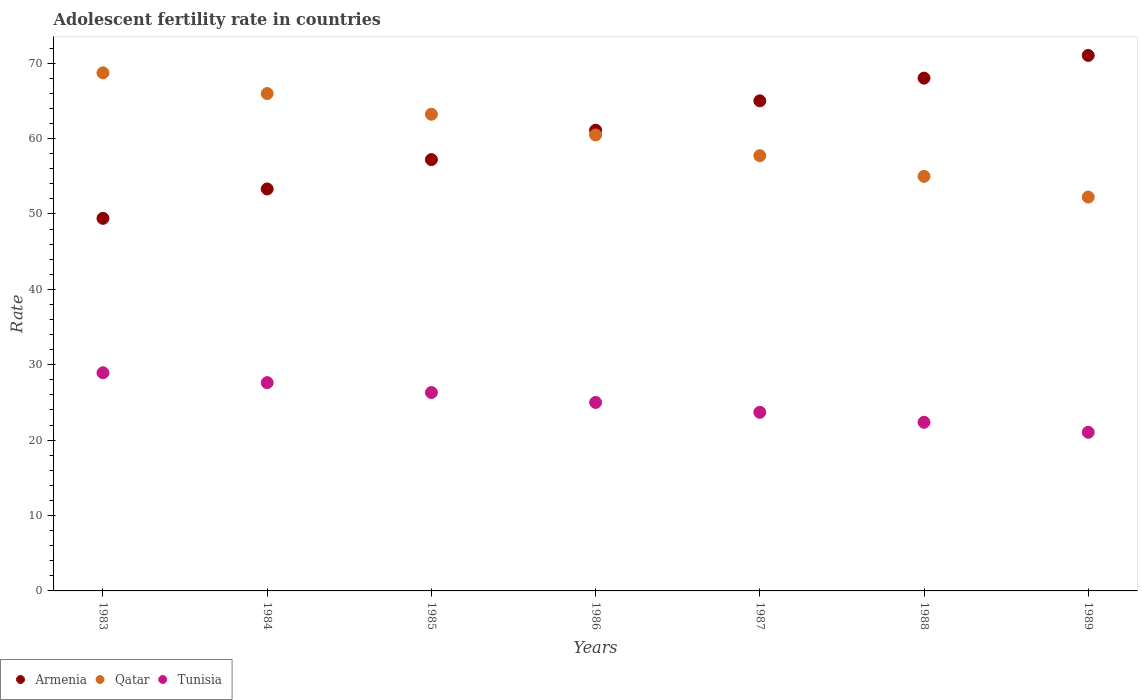Is the number of dotlines equal to the number of legend labels?
Keep it short and to the point. Yes. What is the adolescent fertility rate in Armenia in 1983?
Ensure brevity in your answer.  49.42. Across all years, what is the maximum adolescent fertility rate in Armenia?
Your answer should be very brief. 71.03. Across all years, what is the minimum adolescent fertility rate in Qatar?
Your response must be concise. 52.24. In which year was the adolescent fertility rate in Tunisia maximum?
Make the answer very short. 1983. What is the total adolescent fertility rate in Armenia in the graph?
Make the answer very short. 425.12. What is the difference between the adolescent fertility rate in Tunisia in 1987 and that in 1989?
Provide a succinct answer. 2.65. What is the difference between the adolescent fertility rate in Tunisia in 1984 and the adolescent fertility rate in Armenia in 1986?
Offer a very short reply. -33.48. What is the average adolescent fertility rate in Tunisia per year?
Keep it short and to the point. 25. In the year 1985, what is the difference between the adolescent fertility rate in Qatar and adolescent fertility rate in Tunisia?
Provide a short and direct response. 36.91. What is the ratio of the adolescent fertility rate in Qatar in 1988 to that in 1989?
Provide a short and direct response. 1.05. Is the adolescent fertility rate in Tunisia in 1984 less than that in 1987?
Make the answer very short. No. What is the difference between the highest and the second highest adolescent fertility rate in Armenia?
Give a very brief answer. 3.01. What is the difference between the highest and the lowest adolescent fertility rate in Tunisia?
Offer a very short reply. 7.9. In how many years, is the adolescent fertility rate in Armenia greater than the average adolescent fertility rate in Armenia taken over all years?
Give a very brief answer. 4. Is the sum of the adolescent fertility rate in Tunisia in 1984 and 1989 greater than the maximum adolescent fertility rate in Qatar across all years?
Give a very brief answer. No. Is it the case that in every year, the sum of the adolescent fertility rate in Qatar and adolescent fertility rate in Tunisia  is greater than the adolescent fertility rate in Armenia?
Your response must be concise. Yes. Is the adolescent fertility rate in Tunisia strictly greater than the adolescent fertility rate in Armenia over the years?
Keep it short and to the point. No. Is the adolescent fertility rate in Tunisia strictly less than the adolescent fertility rate in Armenia over the years?
Keep it short and to the point. Yes. How many years are there in the graph?
Offer a very short reply. 7. Does the graph contain any zero values?
Keep it short and to the point. No. Where does the legend appear in the graph?
Provide a succinct answer. Bottom left. How are the legend labels stacked?
Provide a succinct answer. Horizontal. What is the title of the graph?
Offer a very short reply. Adolescent fertility rate in countries. What is the label or title of the Y-axis?
Your answer should be very brief. Rate. What is the Rate in Armenia in 1983?
Offer a terse response. 49.42. What is the Rate in Qatar in 1983?
Provide a succinct answer. 68.72. What is the Rate in Tunisia in 1983?
Provide a succinct answer. 28.94. What is the Rate of Armenia in 1984?
Offer a very short reply. 53.32. What is the Rate in Qatar in 1984?
Keep it short and to the point. 65.98. What is the Rate in Tunisia in 1984?
Keep it short and to the point. 27.63. What is the Rate in Armenia in 1985?
Give a very brief answer. 57.21. What is the Rate in Qatar in 1985?
Offer a very short reply. 63.23. What is the Rate of Tunisia in 1985?
Provide a succinct answer. 26.31. What is the Rate in Armenia in 1986?
Keep it short and to the point. 61.11. What is the Rate in Qatar in 1986?
Offer a very short reply. 60.48. What is the Rate in Tunisia in 1986?
Provide a succinct answer. 25. What is the Rate in Armenia in 1987?
Your response must be concise. 65.01. What is the Rate of Qatar in 1987?
Ensure brevity in your answer.  57.74. What is the Rate in Tunisia in 1987?
Your response must be concise. 23.69. What is the Rate of Armenia in 1988?
Provide a succinct answer. 68.02. What is the Rate in Qatar in 1988?
Keep it short and to the point. 54.99. What is the Rate of Tunisia in 1988?
Provide a short and direct response. 22.37. What is the Rate of Armenia in 1989?
Your answer should be compact. 71.03. What is the Rate in Qatar in 1989?
Offer a very short reply. 52.24. What is the Rate of Tunisia in 1989?
Your answer should be compact. 21.04. Across all years, what is the maximum Rate in Armenia?
Provide a short and direct response. 71.03. Across all years, what is the maximum Rate of Qatar?
Offer a terse response. 68.72. Across all years, what is the maximum Rate in Tunisia?
Make the answer very short. 28.94. Across all years, what is the minimum Rate of Armenia?
Your response must be concise. 49.42. Across all years, what is the minimum Rate in Qatar?
Make the answer very short. 52.24. Across all years, what is the minimum Rate of Tunisia?
Ensure brevity in your answer.  21.04. What is the total Rate in Armenia in the graph?
Keep it short and to the point. 425.12. What is the total Rate of Qatar in the graph?
Ensure brevity in your answer.  423.38. What is the total Rate of Tunisia in the graph?
Your response must be concise. 174.98. What is the difference between the Rate of Armenia in 1983 and that in 1984?
Make the answer very short. -3.9. What is the difference between the Rate in Qatar in 1983 and that in 1984?
Your response must be concise. 2.75. What is the difference between the Rate of Tunisia in 1983 and that in 1984?
Offer a terse response. 1.31. What is the difference between the Rate of Armenia in 1983 and that in 1985?
Offer a very short reply. -7.79. What is the difference between the Rate of Qatar in 1983 and that in 1985?
Make the answer very short. 5.49. What is the difference between the Rate of Tunisia in 1983 and that in 1985?
Provide a succinct answer. 2.62. What is the difference between the Rate of Armenia in 1983 and that in 1986?
Your response must be concise. -11.69. What is the difference between the Rate in Qatar in 1983 and that in 1986?
Ensure brevity in your answer.  8.24. What is the difference between the Rate of Tunisia in 1983 and that in 1986?
Provide a succinct answer. 3.94. What is the difference between the Rate of Armenia in 1983 and that in 1987?
Make the answer very short. -15.59. What is the difference between the Rate of Qatar in 1983 and that in 1987?
Offer a very short reply. 10.99. What is the difference between the Rate in Tunisia in 1983 and that in 1987?
Provide a succinct answer. 5.25. What is the difference between the Rate of Armenia in 1983 and that in 1988?
Offer a very short reply. -18.6. What is the difference between the Rate of Qatar in 1983 and that in 1988?
Give a very brief answer. 13.73. What is the difference between the Rate in Tunisia in 1983 and that in 1988?
Offer a very short reply. 6.57. What is the difference between the Rate in Armenia in 1983 and that in 1989?
Provide a succinct answer. -21.61. What is the difference between the Rate of Qatar in 1983 and that in 1989?
Offer a terse response. 16.48. What is the difference between the Rate of Tunisia in 1983 and that in 1989?
Give a very brief answer. 7.9. What is the difference between the Rate of Armenia in 1984 and that in 1985?
Provide a succinct answer. -3.9. What is the difference between the Rate of Qatar in 1984 and that in 1985?
Offer a terse response. 2.75. What is the difference between the Rate in Tunisia in 1984 and that in 1985?
Your answer should be very brief. 1.31. What is the difference between the Rate of Armenia in 1984 and that in 1986?
Your answer should be very brief. -7.79. What is the difference between the Rate of Qatar in 1984 and that in 1986?
Provide a succinct answer. 5.49. What is the difference between the Rate in Tunisia in 1984 and that in 1986?
Your answer should be compact. 2.62. What is the difference between the Rate in Armenia in 1984 and that in 1987?
Your response must be concise. -11.69. What is the difference between the Rate of Qatar in 1984 and that in 1987?
Offer a very short reply. 8.24. What is the difference between the Rate of Tunisia in 1984 and that in 1987?
Give a very brief answer. 3.94. What is the difference between the Rate of Armenia in 1984 and that in 1988?
Keep it short and to the point. -14.7. What is the difference between the Rate of Qatar in 1984 and that in 1988?
Your response must be concise. 10.98. What is the difference between the Rate of Tunisia in 1984 and that in 1988?
Give a very brief answer. 5.26. What is the difference between the Rate of Armenia in 1984 and that in 1989?
Your response must be concise. -17.71. What is the difference between the Rate in Qatar in 1984 and that in 1989?
Your answer should be compact. 13.73. What is the difference between the Rate in Tunisia in 1984 and that in 1989?
Ensure brevity in your answer.  6.58. What is the difference between the Rate of Armenia in 1985 and that in 1986?
Make the answer very short. -3.9. What is the difference between the Rate of Qatar in 1985 and that in 1986?
Give a very brief answer. 2.75. What is the difference between the Rate of Tunisia in 1985 and that in 1986?
Your response must be concise. 1.31. What is the difference between the Rate in Armenia in 1985 and that in 1987?
Offer a terse response. -7.79. What is the difference between the Rate of Qatar in 1985 and that in 1987?
Your response must be concise. 5.49. What is the difference between the Rate of Tunisia in 1985 and that in 1987?
Provide a short and direct response. 2.62. What is the difference between the Rate of Armenia in 1985 and that in 1988?
Provide a short and direct response. -10.81. What is the difference between the Rate in Qatar in 1985 and that in 1988?
Give a very brief answer. 8.24. What is the difference between the Rate of Tunisia in 1985 and that in 1988?
Give a very brief answer. 3.95. What is the difference between the Rate of Armenia in 1985 and that in 1989?
Make the answer very short. -13.82. What is the difference between the Rate of Qatar in 1985 and that in 1989?
Offer a very short reply. 10.98. What is the difference between the Rate in Tunisia in 1985 and that in 1989?
Your response must be concise. 5.27. What is the difference between the Rate in Armenia in 1986 and that in 1987?
Offer a terse response. -3.9. What is the difference between the Rate in Qatar in 1986 and that in 1987?
Provide a short and direct response. 2.75. What is the difference between the Rate of Tunisia in 1986 and that in 1987?
Provide a succinct answer. 1.31. What is the difference between the Rate of Armenia in 1986 and that in 1988?
Offer a terse response. -6.91. What is the difference between the Rate in Qatar in 1986 and that in 1988?
Keep it short and to the point. 5.49. What is the difference between the Rate of Tunisia in 1986 and that in 1988?
Your answer should be very brief. 2.64. What is the difference between the Rate in Armenia in 1986 and that in 1989?
Ensure brevity in your answer.  -9.92. What is the difference between the Rate of Qatar in 1986 and that in 1989?
Ensure brevity in your answer.  8.24. What is the difference between the Rate in Tunisia in 1986 and that in 1989?
Your answer should be compact. 3.96. What is the difference between the Rate of Armenia in 1987 and that in 1988?
Provide a short and direct response. -3.01. What is the difference between the Rate of Qatar in 1987 and that in 1988?
Your answer should be very brief. 2.75. What is the difference between the Rate in Tunisia in 1987 and that in 1988?
Offer a very short reply. 1.32. What is the difference between the Rate in Armenia in 1987 and that in 1989?
Your response must be concise. -6.02. What is the difference between the Rate in Qatar in 1987 and that in 1989?
Make the answer very short. 5.49. What is the difference between the Rate in Tunisia in 1987 and that in 1989?
Provide a succinct answer. 2.65. What is the difference between the Rate of Armenia in 1988 and that in 1989?
Your answer should be compact. -3.01. What is the difference between the Rate of Qatar in 1988 and that in 1989?
Offer a terse response. 2.75. What is the difference between the Rate in Tunisia in 1988 and that in 1989?
Keep it short and to the point. 1.32. What is the difference between the Rate in Armenia in 1983 and the Rate in Qatar in 1984?
Your response must be concise. -16.55. What is the difference between the Rate of Armenia in 1983 and the Rate of Tunisia in 1984?
Your answer should be compact. 21.79. What is the difference between the Rate in Qatar in 1983 and the Rate in Tunisia in 1984?
Give a very brief answer. 41.1. What is the difference between the Rate of Armenia in 1983 and the Rate of Qatar in 1985?
Provide a short and direct response. -13.81. What is the difference between the Rate in Armenia in 1983 and the Rate in Tunisia in 1985?
Ensure brevity in your answer.  23.11. What is the difference between the Rate in Qatar in 1983 and the Rate in Tunisia in 1985?
Provide a short and direct response. 42.41. What is the difference between the Rate of Armenia in 1983 and the Rate of Qatar in 1986?
Provide a succinct answer. -11.06. What is the difference between the Rate in Armenia in 1983 and the Rate in Tunisia in 1986?
Ensure brevity in your answer.  24.42. What is the difference between the Rate of Qatar in 1983 and the Rate of Tunisia in 1986?
Your answer should be compact. 43.72. What is the difference between the Rate of Armenia in 1983 and the Rate of Qatar in 1987?
Your answer should be very brief. -8.32. What is the difference between the Rate of Armenia in 1983 and the Rate of Tunisia in 1987?
Keep it short and to the point. 25.73. What is the difference between the Rate in Qatar in 1983 and the Rate in Tunisia in 1987?
Your answer should be very brief. 45.03. What is the difference between the Rate in Armenia in 1983 and the Rate in Qatar in 1988?
Your answer should be very brief. -5.57. What is the difference between the Rate of Armenia in 1983 and the Rate of Tunisia in 1988?
Your answer should be very brief. 27.05. What is the difference between the Rate of Qatar in 1983 and the Rate of Tunisia in 1988?
Keep it short and to the point. 46.35. What is the difference between the Rate in Armenia in 1983 and the Rate in Qatar in 1989?
Your response must be concise. -2.82. What is the difference between the Rate of Armenia in 1983 and the Rate of Tunisia in 1989?
Your answer should be compact. 28.38. What is the difference between the Rate of Qatar in 1983 and the Rate of Tunisia in 1989?
Provide a succinct answer. 47.68. What is the difference between the Rate of Armenia in 1984 and the Rate of Qatar in 1985?
Make the answer very short. -9.91. What is the difference between the Rate of Armenia in 1984 and the Rate of Tunisia in 1985?
Provide a short and direct response. 27. What is the difference between the Rate of Qatar in 1984 and the Rate of Tunisia in 1985?
Your answer should be compact. 39.66. What is the difference between the Rate in Armenia in 1984 and the Rate in Qatar in 1986?
Ensure brevity in your answer.  -7.16. What is the difference between the Rate in Armenia in 1984 and the Rate in Tunisia in 1986?
Provide a succinct answer. 28.31. What is the difference between the Rate in Qatar in 1984 and the Rate in Tunisia in 1986?
Make the answer very short. 40.97. What is the difference between the Rate in Armenia in 1984 and the Rate in Qatar in 1987?
Provide a succinct answer. -4.42. What is the difference between the Rate of Armenia in 1984 and the Rate of Tunisia in 1987?
Your answer should be compact. 29.63. What is the difference between the Rate of Qatar in 1984 and the Rate of Tunisia in 1987?
Offer a very short reply. 42.28. What is the difference between the Rate in Armenia in 1984 and the Rate in Qatar in 1988?
Make the answer very short. -1.67. What is the difference between the Rate in Armenia in 1984 and the Rate in Tunisia in 1988?
Your answer should be compact. 30.95. What is the difference between the Rate of Qatar in 1984 and the Rate of Tunisia in 1988?
Give a very brief answer. 43.61. What is the difference between the Rate in Armenia in 1984 and the Rate in Qatar in 1989?
Provide a short and direct response. 1.07. What is the difference between the Rate of Armenia in 1984 and the Rate of Tunisia in 1989?
Your response must be concise. 32.28. What is the difference between the Rate of Qatar in 1984 and the Rate of Tunisia in 1989?
Offer a terse response. 44.93. What is the difference between the Rate of Armenia in 1985 and the Rate of Qatar in 1986?
Offer a very short reply. -3.27. What is the difference between the Rate in Armenia in 1985 and the Rate in Tunisia in 1986?
Your answer should be very brief. 32.21. What is the difference between the Rate in Qatar in 1985 and the Rate in Tunisia in 1986?
Give a very brief answer. 38.23. What is the difference between the Rate in Armenia in 1985 and the Rate in Qatar in 1987?
Ensure brevity in your answer.  -0.52. What is the difference between the Rate of Armenia in 1985 and the Rate of Tunisia in 1987?
Provide a succinct answer. 33.52. What is the difference between the Rate of Qatar in 1985 and the Rate of Tunisia in 1987?
Your response must be concise. 39.54. What is the difference between the Rate in Armenia in 1985 and the Rate in Qatar in 1988?
Provide a succinct answer. 2.22. What is the difference between the Rate of Armenia in 1985 and the Rate of Tunisia in 1988?
Your answer should be compact. 34.85. What is the difference between the Rate of Qatar in 1985 and the Rate of Tunisia in 1988?
Keep it short and to the point. 40.86. What is the difference between the Rate in Armenia in 1985 and the Rate in Qatar in 1989?
Your answer should be very brief. 4.97. What is the difference between the Rate of Armenia in 1985 and the Rate of Tunisia in 1989?
Ensure brevity in your answer.  36.17. What is the difference between the Rate in Qatar in 1985 and the Rate in Tunisia in 1989?
Your answer should be very brief. 42.19. What is the difference between the Rate of Armenia in 1986 and the Rate of Qatar in 1987?
Offer a terse response. 3.38. What is the difference between the Rate of Armenia in 1986 and the Rate of Tunisia in 1987?
Your answer should be compact. 37.42. What is the difference between the Rate in Qatar in 1986 and the Rate in Tunisia in 1987?
Offer a very short reply. 36.79. What is the difference between the Rate of Armenia in 1986 and the Rate of Qatar in 1988?
Keep it short and to the point. 6.12. What is the difference between the Rate in Armenia in 1986 and the Rate in Tunisia in 1988?
Ensure brevity in your answer.  38.74. What is the difference between the Rate of Qatar in 1986 and the Rate of Tunisia in 1988?
Give a very brief answer. 38.12. What is the difference between the Rate of Armenia in 1986 and the Rate of Qatar in 1989?
Your answer should be very brief. 8.87. What is the difference between the Rate in Armenia in 1986 and the Rate in Tunisia in 1989?
Provide a succinct answer. 40.07. What is the difference between the Rate of Qatar in 1986 and the Rate of Tunisia in 1989?
Provide a succinct answer. 39.44. What is the difference between the Rate in Armenia in 1987 and the Rate in Qatar in 1988?
Provide a succinct answer. 10.02. What is the difference between the Rate of Armenia in 1987 and the Rate of Tunisia in 1988?
Your answer should be very brief. 42.64. What is the difference between the Rate of Qatar in 1987 and the Rate of Tunisia in 1988?
Ensure brevity in your answer.  35.37. What is the difference between the Rate in Armenia in 1987 and the Rate in Qatar in 1989?
Provide a short and direct response. 12.76. What is the difference between the Rate in Armenia in 1987 and the Rate in Tunisia in 1989?
Ensure brevity in your answer.  43.97. What is the difference between the Rate of Qatar in 1987 and the Rate of Tunisia in 1989?
Your answer should be compact. 36.69. What is the difference between the Rate in Armenia in 1988 and the Rate in Qatar in 1989?
Ensure brevity in your answer.  15.78. What is the difference between the Rate of Armenia in 1988 and the Rate of Tunisia in 1989?
Provide a short and direct response. 46.98. What is the difference between the Rate in Qatar in 1988 and the Rate in Tunisia in 1989?
Your response must be concise. 33.95. What is the average Rate of Armenia per year?
Your answer should be very brief. 60.73. What is the average Rate of Qatar per year?
Your answer should be compact. 60.48. What is the average Rate of Tunisia per year?
Your answer should be compact. 25. In the year 1983, what is the difference between the Rate of Armenia and Rate of Qatar?
Ensure brevity in your answer.  -19.3. In the year 1983, what is the difference between the Rate in Armenia and Rate in Tunisia?
Keep it short and to the point. 20.48. In the year 1983, what is the difference between the Rate in Qatar and Rate in Tunisia?
Give a very brief answer. 39.78. In the year 1984, what is the difference between the Rate in Armenia and Rate in Qatar?
Provide a short and direct response. -12.66. In the year 1984, what is the difference between the Rate of Armenia and Rate of Tunisia?
Provide a succinct answer. 25.69. In the year 1984, what is the difference between the Rate of Qatar and Rate of Tunisia?
Your answer should be very brief. 38.35. In the year 1985, what is the difference between the Rate in Armenia and Rate in Qatar?
Provide a succinct answer. -6.01. In the year 1985, what is the difference between the Rate of Armenia and Rate of Tunisia?
Ensure brevity in your answer.  30.9. In the year 1985, what is the difference between the Rate of Qatar and Rate of Tunisia?
Offer a terse response. 36.91. In the year 1986, what is the difference between the Rate in Armenia and Rate in Qatar?
Your response must be concise. 0.63. In the year 1986, what is the difference between the Rate of Armenia and Rate of Tunisia?
Your response must be concise. 36.11. In the year 1986, what is the difference between the Rate of Qatar and Rate of Tunisia?
Provide a succinct answer. 35.48. In the year 1987, what is the difference between the Rate of Armenia and Rate of Qatar?
Offer a terse response. 7.27. In the year 1987, what is the difference between the Rate in Armenia and Rate in Tunisia?
Your answer should be compact. 41.32. In the year 1987, what is the difference between the Rate in Qatar and Rate in Tunisia?
Offer a very short reply. 34.05. In the year 1988, what is the difference between the Rate of Armenia and Rate of Qatar?
Give a very brief answer. 13.03. In the year 1988, what is the difference between the Rate of Armenia and Rate of Tunisia?
Your answer should be compact. 45.65. In the year 1988, what is the difference between the Rate in Qatar and Rate in Tunisia?
Make the answer very short. 32.62. In the year 1989, what is the difference between the Rate in Armenia and Rate in Qatar?
Your answer should be compact. 18.79. In the year 1989, what is the difference between the Rate of Armenia and Rate of Tunisia?
Make the answer very short. 49.99. In the year 1989, what is the difference between the Rate in Qatar and Rate in Tunisia?
Your response must be concise. 31.2. What is the ratio of the Rate in Armenia in 1983 to that in 1984?
Make the answer very short. 0.93. What is the ratio of the Rate of Qatar in 1983 to that in 1984?
Give a very brief answer. 1.04. What is the ratio of the Rate of Tunisia in 1983 to that in 1984?
Your answer should be compact. 1.05. What is the ratio of the Rate of Armenia in 1983 to that in 1985?
Give a very brief answer. 0.86. What is the ratio of the Rate of Qatar in 1983 to that in 1985?
Your response must be concise. 1.09. What is the ratio of the Rate of Tunisia in 1983 to that in 1985?
Offer a very short reply. 1.1. What is the ratio of the Rate in Armenia in 1983 to that in 1986?
Give a very brief answer. 0.81. What is the ratio of the Rate in Qatar in 1983 to that in 1986?
Your response must be concise. 1.14. What is the ratio of the Rate of Tunisia in 1983 to that in 1986?
Give a very brief answer. 1.16. What is the ratio of the Rate of Armenia in 1983 to that in 1987?
Your answer should be compact. 0.76. What is the ratio of the Rate of Qatar in 1983 to that in 1987?
Offer a terse response. 1.19. What is the ratio of the Rate in Tunisia in 1983 to that in 1987?
Your answer should be compact. 1.22. What is the ratio of the Rate in Armenia in 1983 to that in 1988?
Provide a succinct answer. 0.73. What is the ratio of the Rate of Qatar in 1983 to that in 1988?
Offer a terse response. 1.25. What is the ratio of the Rate of Tunisia in 1983 to that in 1988?
Provide a short and direct response. 1.29. What is the ratio of the Rate of Armenia in 1983 to that in 1989?
Your answer should be compact. 0.7. What is the ratio of the Rate in Qatar in 1983 to that in 1989?
Provide a short and direct response. 1.32. What is the ratio of the Rate in Tunisia in 1983 to that in 1989?
Offer a very short reply. 1.38. What is the ratio of the Rate in Armenia in 1984 to that in 1985?
Ensure brevity in your answer.  0.93. What is the ratio of the Rate of Qatar in 1984 to that in 1985?
Your answer should be compact. 1.04. What is the ratio of the Rate of Tunisia in 1984 to that in 1985?
Provide a succinct answer. 1.05. What is the ratio of the Rate in Armenia in 1984 to that in 1986?
Offer a very short reply. 0.87. What is the ratio of the Rate in Qatar in 1984 to that in 1986?
Make the answer very short. 1.09. What is the ratio of the Rate of Tunisia in 1984 to that in 1986?
Keep it short and to the point. 1.1. What is the ratio of the Rate of Armenia in 1984 to that in 1987?
Your response must be concise. 0.82. What is the ratio of the Rate of Qatar in 1984 to that in 1987?
Make the answer very short. 1.14. What is the ratio of the Rate in Tunisia in 1984 to that in 1987?
Offer a very short reply. 1.17. What is the ratio of the Rate of Armenia in 1984 to that in 1988?
Your answer should be compact. 0.78. What is the ratio of the Rate in Qatar in 1984 to that in 1988?
Keep it short and to the point. 1.2. What is the ratio of the Rate in Tunisia in 1984 to that in 1988?
Offer a terse response. 1.24. What is the ratio of the Rate of Armenia in 1984 to that in 1989?
Provide a succinct answer. 0.75. What is the ratio of the Rate of Qatar in 1984 to that in 1989?
Provide a short and direct response. 1.26. What is the ratio of the Rate of Tunisia in 1984 to that in 1989?
Your answer should be very brief. 1.31. What is the ratio of the Rate in Armenia in 1985 to that in 1986?
Make the answer very short. 0.94. What is the ratio of the Rate in Qatar in 1985 to that in 1986?
Your response must be concise. 1.05. What is the ratio of the Rate in Tunisia in 1985 to that in 1986?
Offer a very short reply. 1.05. What is the ratio of the Rate of Armenia in 1985 to that in 1987?
Offer a very short reply. 0.88. What is the ratio of the Rate of Qatar in 1985 to that in 1987?
Make the answer very short. 1.1. What is the ratio of the Rate of Tunisia in 1985 to that in 1987?
Your response must be concise. 1.11. What is the ratio of the Rate of Armenia in 1985 to that in 1988?
Provide a short and direct response. 0.84. What is the ratio of the Rate of Qatar in 1985 to that in 1988?
Provide a succinct answer. 1.15. What is the ratio of the Rate of Tunisia in 1985 to that in 1988?
Make the answer very short. 1.18. What is the ratio of the Rate in Armenia in 1985 to that in 1989?
Provide a short and direct response. 0.81. What is the ratio of the Rate in Qatar in 1985 to that in 1989?
Ensure brevity in your answer.  1.21. What is the ratio of the Rate of Tunisia in 1985 to that in 1989?
Make the answer very short. 1.25. What is the ratio of the Rate in Armenia in 1986 to that in 1987?
Make the answer very short. 0.94. What is the ratio of the Rate in Qatar in 1986 to that in 1987?
Your answer should be very brief. 1.05. What is the ratio of the Rate of Tunisia in 1986 to that in 1987?
Ensure brevity in your answer.  1.06. What is the ratio of the Rate of Armenia in 1986 to that in 1988?
Offer a terse response. 0.9. What is the ratio of the Rate in Qatar in 1986 to that in 1988?
Your answer should be very brief. 1.1. What is the ratio of the Rate in Tunisia in 1986 to that in 1988?
Make the answer very short. 1.12. What is the ratio of the Rate of Armenia in 1986 to that in 1989?
Your answer should be very brief. 0.86. What is the ratio of the Rate of Qatar in 1986 to that in 1989?
Provide a succinct answer. 1.16. What is the ratio of the Rate in Tunisia in 1986 to that in 1989?
Give a very brief answer. 1.19. What is the ratio of the Rate of Armenia in 1987 to that in 1988?
Your response must be concise. 0.96. What is the ratio of the Rate of Qatar in 1987 to that in 1988?
Keep it short and to the point. 1.05. What is the ratio of the Rate in Tunisia in 1987 to that in 1988?
Ensure brevity in your answer.  1.06. What is the ratio of the Rate of Armenia in 1987 to that in 1989?
Give a very brief answer. 0.92. What is the ratio of the Rate of Qatar in 1987 to that in 1989?
Give a very brief answer. 1.11. What is the ratio of the Rate of Tunisia in 1987 to that in 1989?
Provide a succinct answer. 1.13. What is the ratio of the Rate of Armenia in 1988 to that in 1989?
Give a very brief answer. 0.96. What is the ratio of the Rate of Qatar in 1988 to that in 1989?
Ensure brevity in your answer.  1.05. What is the ratio of the Rate in Tunisia in 1988 to that in 1989?
Make the answer very short. 1.06. What is the difference between the highest and the second highest Rate in Armenia?
Provide a succinct answer. 3.01. What is the difference between the highest and the second highest Rate of Qatar?
Your response must be concise. 2.75. What is the difference between the highest and the second highest Rate in Tunisia?
Provide a succinct answer. 1.31. What is the difference between the highest and the lowest Rate of Armenia?
Provide a short and direct response. 21.61. What is the difference between the highest and the lowest Rate of Qatar?
Your answer should be very brief. 16.48. What is the difference between the highest and the lowest Rate of Tunisia?
Provide a succinct answer. 7.9. 